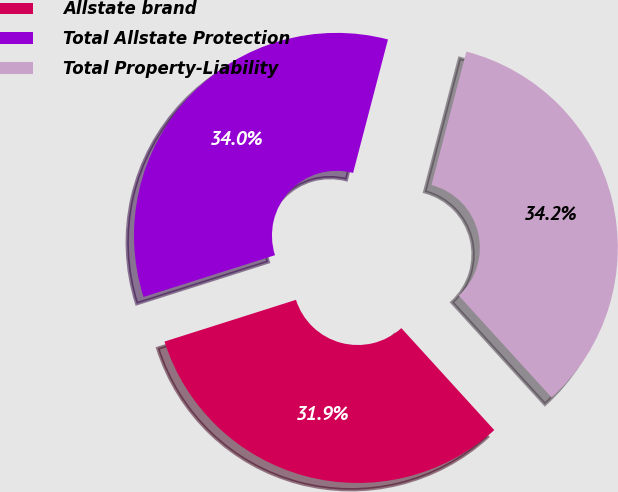Convert chart. <chart><loc_0><loc_0><loc_500><loc_500><pie_chart><fcel>Allstate brand<fcel>Total Allstate Protection<fcel>Total Property-Liability<nl><fcel>31.87%<fcel>33.96%<fcel>34.17%<nl></chart> 